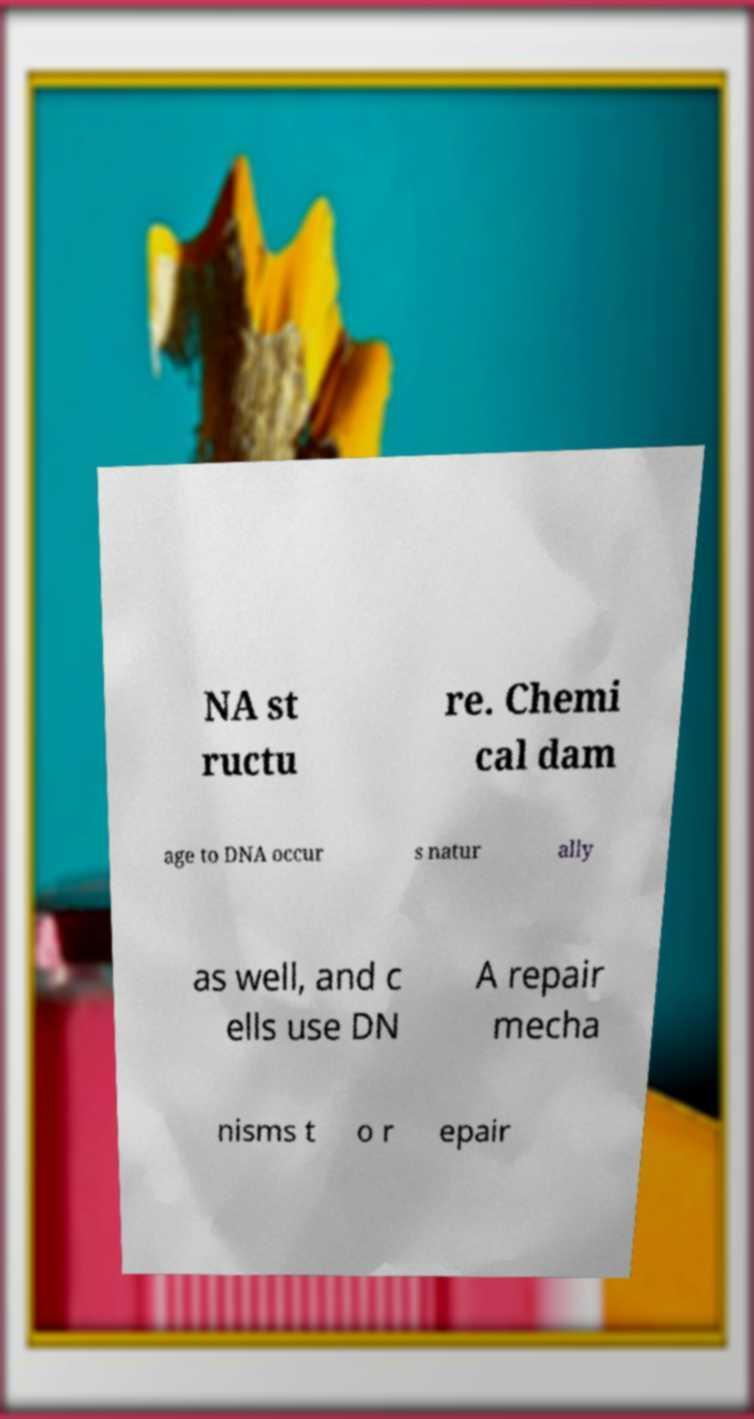Can you accurately transcribe the text from the provided image for me? NA st ructu re. Chemi cal dam age to DNA occur s natur ally as well, and c ells use DN A repair mecha nisms t o r epair 